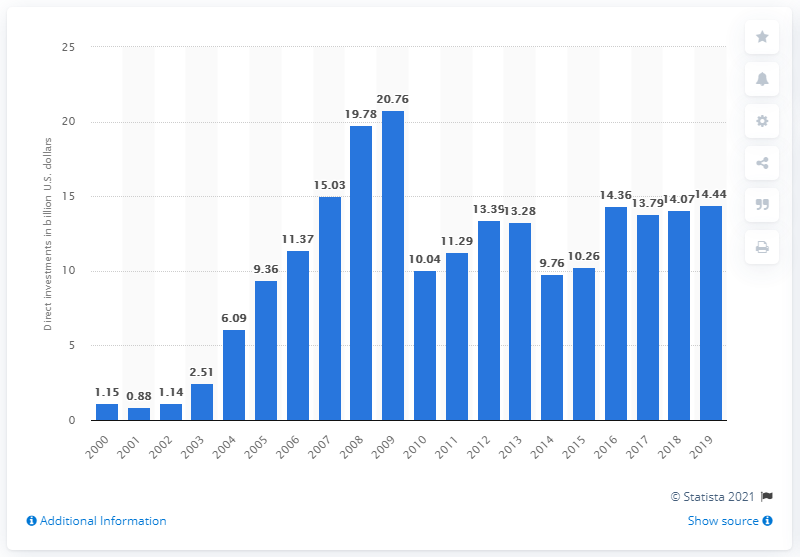Indicate a few pertinent items in this graphic. In 2019, the value of U.S. investments made in Russia was $14.44 billion. 